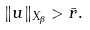<formula> <loc_0><loc_0><loc_500><loc_500>\| u \| _ { X _ { \beta } } > \bar { r } .</formula> 